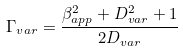Convert formula to latex. <formula><loc_0><loc_0><loc_500><loc_500>\Gamma _ { v a r } = \frac { \beta _ { a p p } ^ { 2 } + D _ { v a r } ^ { 2 } + 1 } { 2 D _ { v a r } }</formula> 